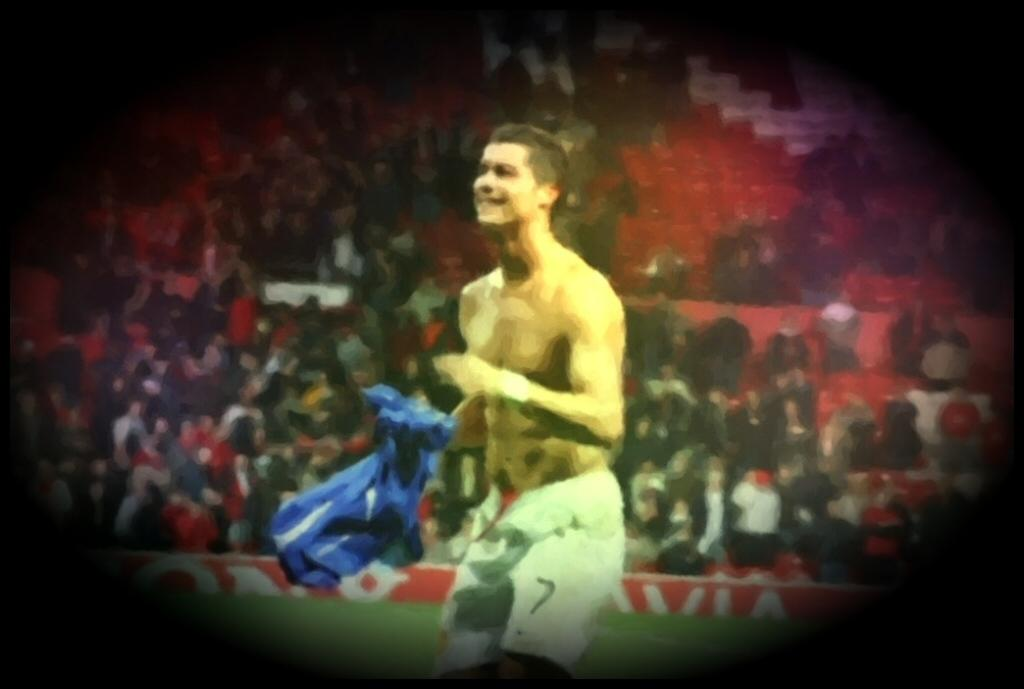What is the man in the image doing? The man is standing in the image. What is the man wearing? The man is wearing shorts. What is the man's facial expression? The man is smiling. Who else can be seen in the image besides the man? There is an audience visible in the image. What type of surface is present in the image? Grass is present in the image. How would you describe the lighting in the image? The corners of the image are dark. How many girls are holding a bomb in the image? There are no girls or bombs present in the image. 